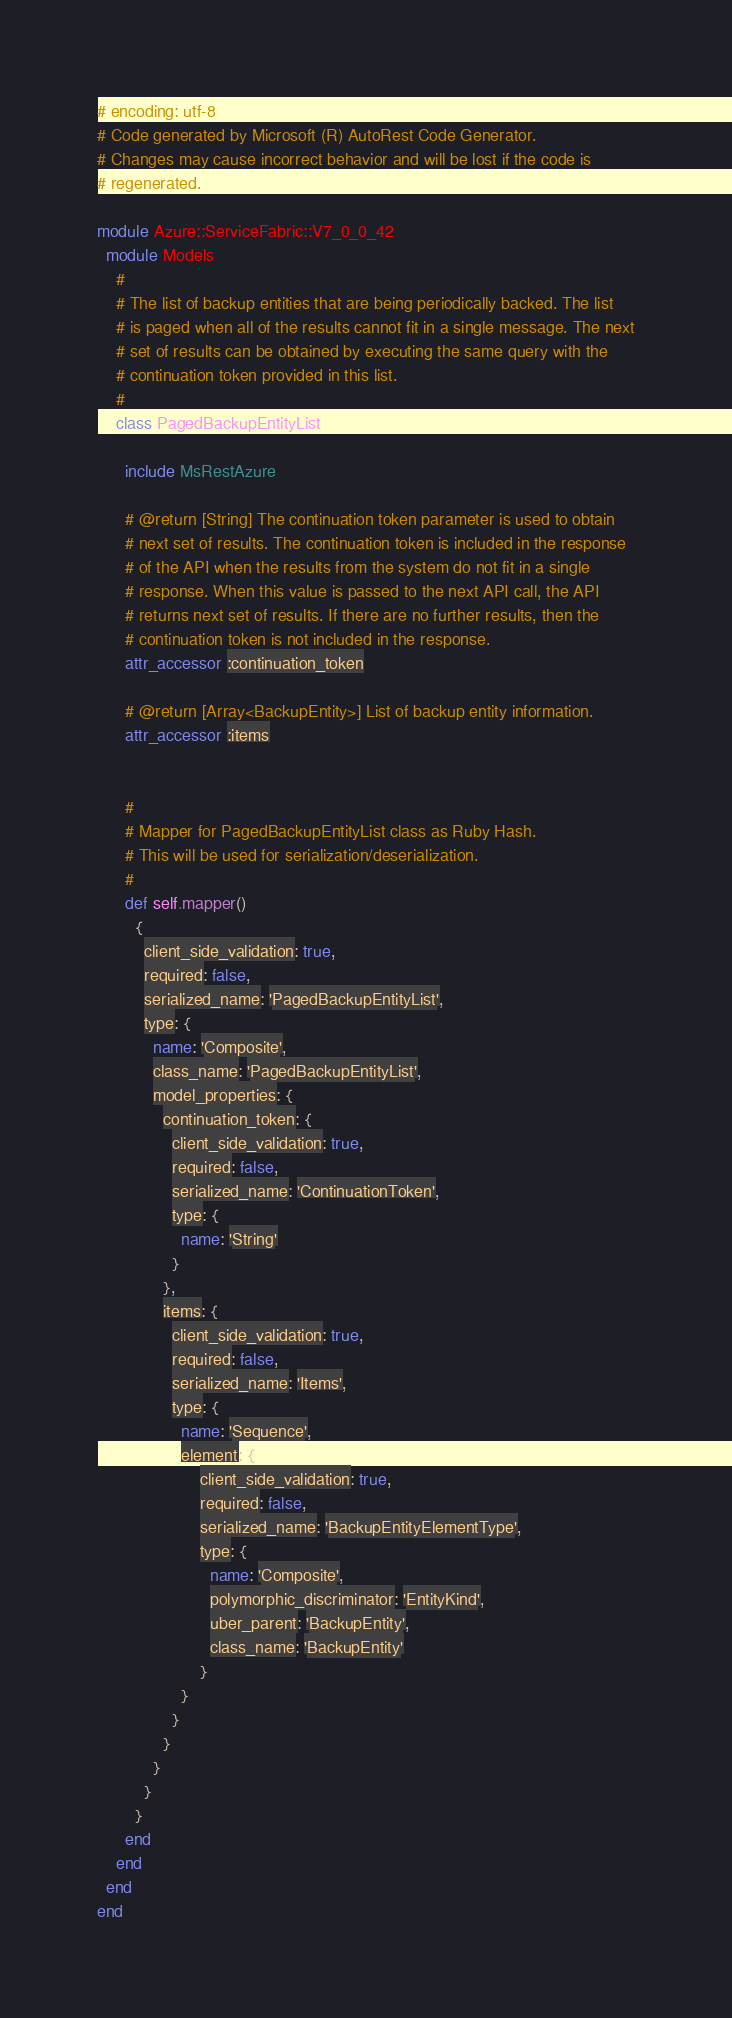<code> <loc_0><loc_0><loc_500><loc_500><_Ruby_># encoding: utf-8
# Code generated by Microsoft (R) AutoRest Code Generator.
# Changes may cause incorrect behavior and will be lost if the code is
# regenerated.

module Azure::ServiceFabric::V7_0_0_42
  module Models
    #
    # The list of backup entities that are being periodically backed. The list
    # is paged when all of the results cannot fit in a single message. The next
    # set of results can be obtained by executing the same query with the
    # continuation token provided in this list.
    #
    class PagedBackupEntityList

      include MsRestAzure

      # @return [String] The continuation token parameter is used to obtain
      # next set of results. The continuation token is included in the response
      # of the API when the results from the system do not fit in a single
      # response. When this value is passed to the next API call, the API
      # returns next set of results. If there are no further results, then the
      # continuation token is not included in the response.
      attr_accessor :continuation_token

      # @return [Array<BackupEntity>] List of backup entity information.
      attr_accessor :items


      #
      # Mapper for PagedBackupEntityList class as Ruby Hash.
      # This will be used for serialization/deserialization.
      #
      def self.mapper()
        {
          client_side_validation: true,
          required: false,
          serialized_name: 'PagedBackupEntityList',
          type: {
            name: 'Composite',
            class_name: 'PagedBackupEntityList',
            model_properties: {
              continuation_token: {
                client_side_validation: true,
                required: false,
                serialized_name: 'ContinuationToken',
                type: {
                  name: 'String'
                }
              },
              items: {
                client_side_validation: true,
                required: false,
                serialized_name: 'Items',
                type: {
                  name: 'Sequence',
                  element: {
                      client_side_validation: true,
                      required: false,
                      serialized_name: 'BackupEntityElementType',
                      type: {
                        name: 'Composite',
                        polymorphic_discriminator: 'EntityKind',
                        uber_parent: 'BackupEntity',
                        class_name: 'BackupEntity'
                      }
                  }
                }
              }
            }
          }
        }
      end
    end
  end
end
</code> 